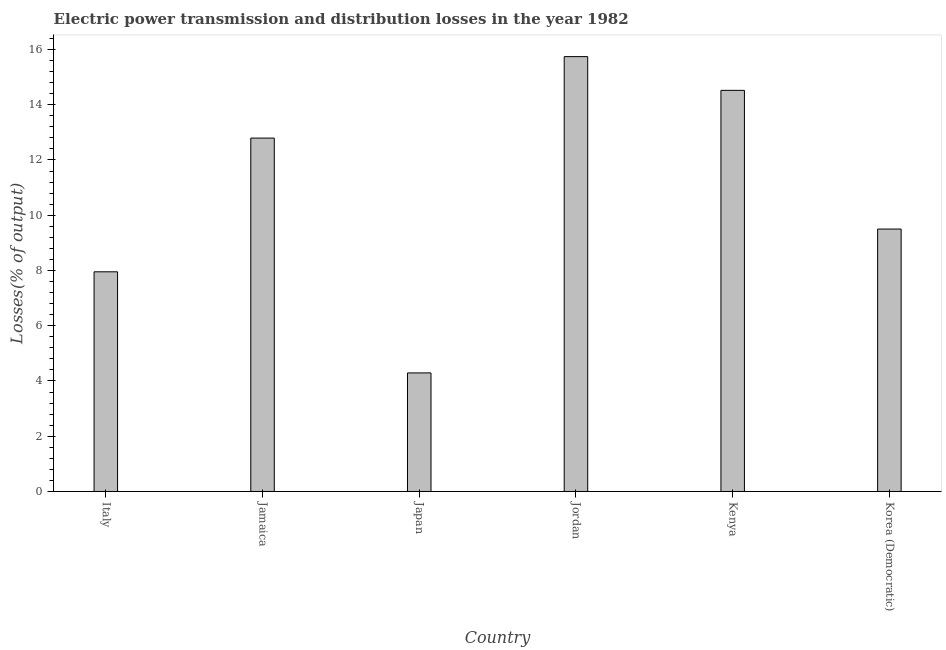Does the graph contain grids?
Offer a terse response. No. What is the title of the graph?
Make the answer very short. Electric power transmission and distribution losses in the year 1982. What is the label or title of the Y-axis?
Keep it short and to the point. Losses(% of output). What is the electric power transmission and distribution losses in Kenya?
Your answer should be compact. 14.52. Across all countries, what is the maximum electric power transmission and distribution losses?
Ensure brevity in your answer.  15.74. Across all countries, what is the minimum electric power transmission and distribution losses?
Ensure brevity in your answer.  4.29. In which country was the electric power transmission and distribution losses maximum?
Your answer should be compact. Jordan. What is the sum of the electric power transmission and distribution losses?
Offer a terse response. 64.79. What is the difference between the electric power transmission and distribution losses in Jamaica and Kenya?
Ensure brevity in your answer.  -1.73. What is the average electric power transmission and distribution losses per country?
Your answer should be very brief. 10.8. What is the median electric power transmission and distribution losses?
Your answer should be very brief. 11.15. What is the ratio of the electric power transmission and distribution losses in Japan to that in Kenya?
Your response must be concise. 0.3. Is the electric power transmission and distribution losses in Japan less than that in Korea (Democratic)?
Ensure brevity in your answer.  Yes. What is the difference between the highest and the second highest electric power transmission and distribution losses?
Offer a terse response. 1.22. What is the difference between the highest and the lowest electric power transmission and distribution losses?
Give a very brief answer. 11.45. How many bars are there?
Give a very brief answer. 6. How many countries are there in the graph?
Make the answer very short. 6. What is the difference between two consecutive major ticks on the Y-axis?
Your response must be concise. 2. Are the values on the major ticks of Y-axis written in scientific E-notation?
Keep it short and to the point. No. What is the Losses(% of output) of Italy?
Make the answer very short. 7.95. What is the Losses(% of output) of Jamaica?
Make the answer very short. 12.79. What is the Losses(% of output) in Japan?
Keep it short and to the point. 4.29. What is the Losses(% of output) in Jordan?
Ensure brevity in your answer.  15.74. What is the Losses(% of output) of Kenya?
Your response must be concise. 14.52. What is the Losses(% of output) of Korea (Democratic)?
Offer a very short reply. 9.5. What is the difference between the Losses(% of output) in Italy and Jamaica?
Provide a short and direct response. -4.84. What is the difference between the Losses(% of output) in Italy and Japan?
Provide a succinct answer. 3.66. What is the difference between the Losses(% of output) in Italy and Jordan?
Your answer should be very brief. -7.79. What is the difference between the Losses(% of output) in Italy and Kenya?
Make the answer very short. -6.57. What is the difference between the Losses(% of output) in Italy and Korea (Democratic)?
Keep it short and to the point. -1.55. What is the difference between the Losses(% of output) in Jamaica and Japan?
Keep it short and to the point. 8.5. What is the difference between the Losses(% of output) in Jamaica and Jordan?
Offer a very short reply. -2.95. What is the difference between the Losses(% of output) in Jamaica and Kenya?
Give a very brief answer. -1.73. What is the difference between the Losses(% of output) in Jamaica and Korea (Democratic)?
Provide a succinct answer. 3.29. What is the difference between the Losses(% of output) in Japan and Jordan?
Provide a short and direct response. -11.45. What is the difference between the Losses(% of output) in Japan and Kenya?
Ensure brevity in your answer.  -10.23. What is the difference between the Losses(% of output) in Japan and Korea (Democratic)?
Your answer should be compact. -5.21. What is the difference between the Losses(% of output) in Jordan and Kenya?
Give a very brief answer. 1.22. What is the difference between the Losses(% of output) in Jordan and Korea (Democratic)?
Your answer should be very brief. 6.24. What is the difference between the Losses(% of output) in Kenya and Korea (Democratic)?
Make the answer very short. 5.02. What is the ratio of the Losses(% of output) in Italy to that in Jamaica?
Your answer should be compact. 0.62. What is the ratio of the Losses(% of output) in Italy to that in Japan?
Offer a terse response. 1.85. What is the ratio of the Losses(% of output) in Italy to that in Jordan?
Provide a succinct answer. 0.51. What is the ratio of the Losses(% of output) in Italy to that in Kenya?
Make the answer very short. 0.55. What is the ratio of the Losses(% of output) in Italy to that in Korea (Democratic)?
Make the answer very short. 0.84. What is the ratio of the Losses(% of output) in Jamaica to that in Japan?
Give a very brief answer. 2.98. What is the ratio of the Losses(% of output) in Jamaica to that in Jordan?
Your response must be concise. 0.81. What is the ratio of the Losses(% of output) in Jamaica to that in Kenya?
Offer a terse response. 0.88. What is the ratio of the Losses(% of output) in Jamaica to that in Korea (Democratic)?
Provide a short and direct response. 1.35. What is the ratio of the Losses(% of output) in Japan to that in Jordan?
Your answer should be very brief. 0.27. What is the ratio of the Losses(% of output) in Japan to that in Kenya?
Offer a terse response. 0.3. What is the ratio of the Losses(% of output) in Japan to that in Korea (Democratic)?
Your answer should be compact. 0.45. What is the ratio of the Losses(% of output) in Jordan to that in Kenya?
Offer a very short reply. 1.08. What is the ratio of the Losses(% of output) in Jordan to that in Korea (Democratic)?
Your answer should be very brief. 1.66. What is the ratio of the Losses(% of output) in Kenya to that in Korea (Democratic)?
Provide a succinct answer. 1.53. 